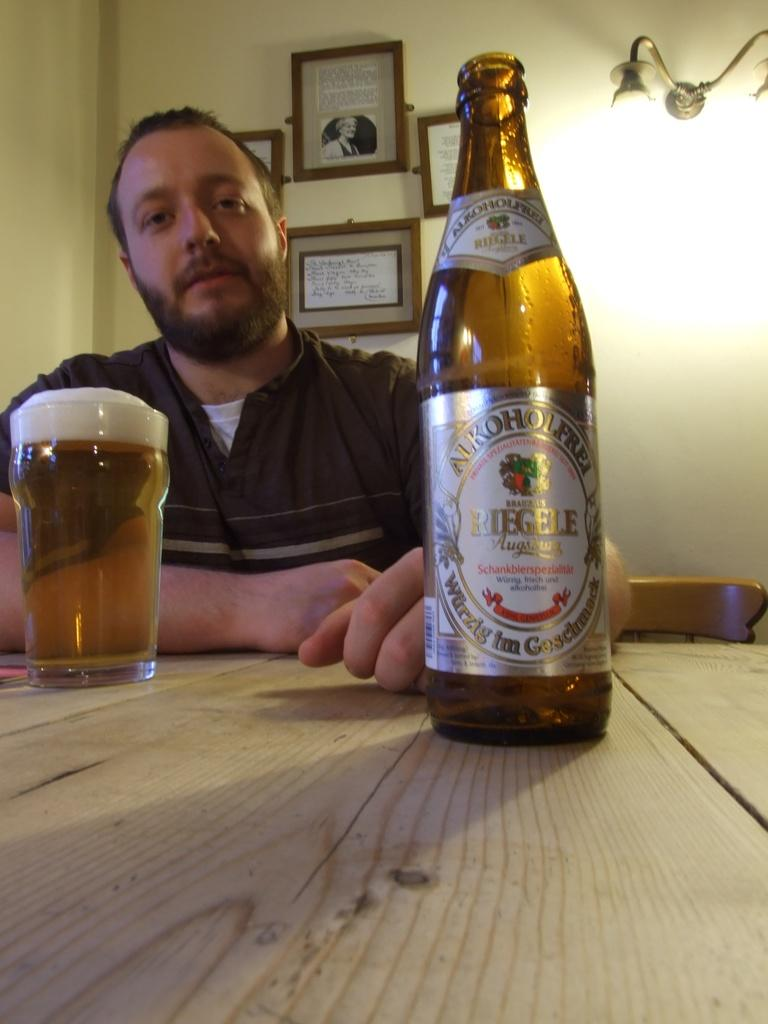<image>
Describe the image concisely. A man with a glass of beer and a bottle Of Riegel Augustus Alkoholfrei 